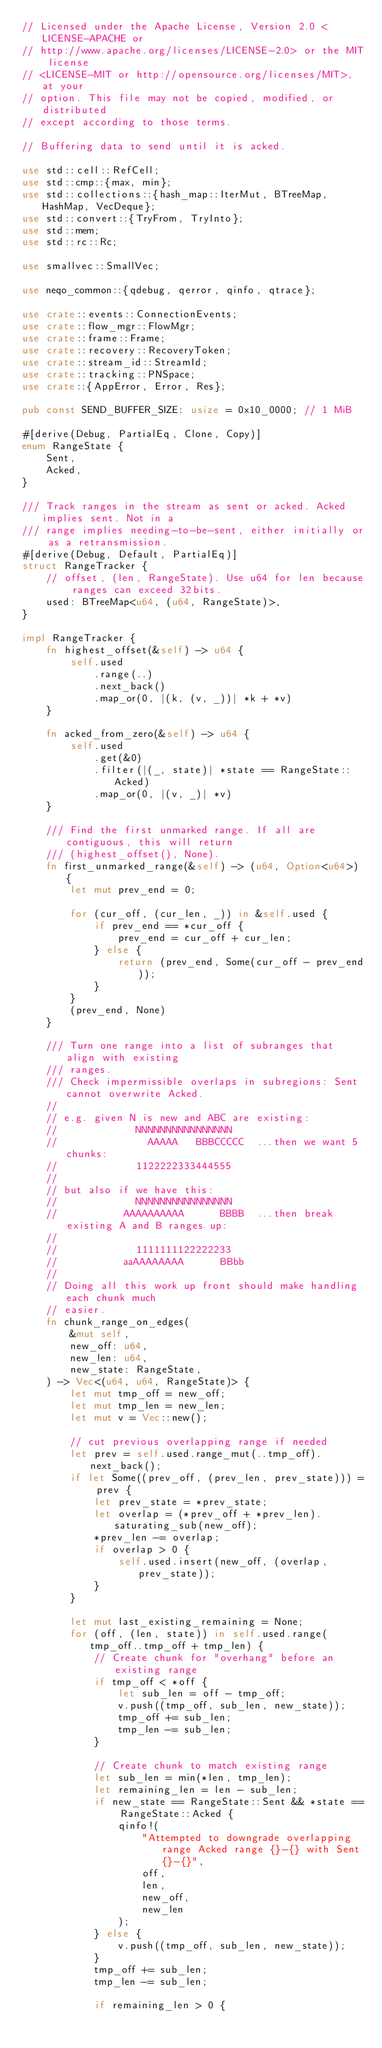Convert code to text. <code><loc_0><loc_0><loc_500><loc_500><_Rust_>// Licensed under the Apache License, Version 2.0 <LICENSE-APACHE or
// http://www.apache.org/licenses/LICENSE-2.0> or the MIT license
// <LICENSE-MIT or http://opensource.org/licenses/MIT>, at your
// option. This file may not be copied, modified, or distributed
// except according to those terms.

// Buffering data to send until it is acked.

use std::cell::RefCell;
use std::cmp::{max, min};
use std::collections::{hash_map::IterMut, BTreeMap, HashMap, VecDeque};
use std::convert::{TryFrom, TryInto};
use std::mem;
use std::rc::Rc;

use smallvec::SmallVec;

use neqo_common::{qdebug, qerror, qinfo, qtrace};

use crate::events::ConnectionEvents;
use crate::flow_mgr::FlowMgr;
use crate::frame::Frame;
use crate::recovery::RecoveryToken;
use crate::stream_id::StreamId;
use crate::tracking::PNSpace;
use crate::{AppError, Error, Res};

pub const SEND_BUFFER_SIZE: usize = 0x10_0000; // 1 MiB

#[derive(Debug, PartialEq, Clone, Copy)]
enum RangeState {
    Sent,
    Acked,
}

/// Track ranges in the stream as sent or acked. Acked implies sent. Not in a
/// range implies needing-to-be-sent, either initially or as a retransmission.
#[derive(Debug, Default, PartialEq)]
struct RangeTracker {
    // offset, (len, RangeState). Use u64 for len because ranges can exceed 32bits.
    used: BTreeMap<u64, (u64, RangeState)>,
}

impl RangeTracker {
    fn highest_offset(&self) -> u64 {
        self.used
            .range(..)
            .next_back()
            .map_or(0, |(k, (v, _))| *k + *v)
    }

    fn acked_from_zero(&self) -> u64 {
        self.used
            .get(&0)
            .filter(|(_, state)| *state == RangeState::Acked)
            .map_or(0, |(v, _)| *v)
    }

    /// Find the first unmarked range. If all are contiguous, this will return
    /// (highest_offset(), None).
    fn first_unmarked_range(&self) -> (u64, Option<u64>) {
        let mut prev_end = 0;

        for (cur_off, (cur_len, _)) in &self.used {
            if prev_end == *cur_off {
                prev_end = cur_off + cur_len;
            } else {
                return (prev_end, Some(cur_off - prev_end));
            }
        }
        (prev_end, None)
    }

    /// Turn one range into a list of subranges that align with existing
    /// ranges.
    /// Check impermissible overlaps in subregions: Sent cannot overwrite Acked.
    //
    // e.g. given N is new and ABC are existing:
    //             NNNNNNNNNNNNNNNN
    //               AAAAA   BBBCCCCC  ...then we want 5 chunks:
    //             1122222333444555
    //
    // but also if we have this:
    //             NNNNNNNNNNNNNNNN
    //           AAAAAAAAAA      BBBB  ...then break existing A and B ranges up:
    //
    //             1111111122222233
    //           aaAAAAAAAA      BBbb
    //
    // Doing all this work up front should make handling each chunk much
    // easier.
    fn chunk_range_on_edges(
        &mut self,
        new_off: u64,
        new_len: u64,
        new_state: RangeState,
    ) -> Vec<(u64, u64, RangeState)> {
        let mut tmp_off = new_off;
        let mut tmp_len = new_len;
        let mut v = Vec::new();

        // cut previous overlapping range if needed
        let prev = self.used.range_mut(..tmp_off).next_back();
        if let Some((prev_off, (prev_len, prev_state))) = prev {
            let prev_state = *prev_state;
            let overlap = (*prev_off + *prev_len).saturating_sub(new_off);
            *prev_len -= overlap;
            if overlap > 0 {
                self.used.insert(new_off, (overlap, prev_state));
            }
        }

        let mut last_existing_remaining = None;
        for (off, (len, state)) in self.used.range(tmp_off..tmp_off + tmp_len) {
            // Create chunk for "overhang" before an existing range
            if tmp_off < *off {
                let sub_len = off - tmp_off;
                v.push((tmp_off, sub_len, new_state));
                tmp_off += sub_len;
                tmp_len -= sub_len;
            }

            // Create chunk to match existing range
            let sub_len = min(*len, tmp_len);
            let remaining_len = len - sub_len;
            if new_state == RangeState::Sent && *state == RangeState::Acked {
                qinfo!(
                    "Attempted to downgrade overlapping range Acked range {}-{} with Sent {}-{}",
                    off,
                    len,
                    new_off,
                    new_len
                );
            } else {
                v.push((tmp_off, sub_len, new_state));
            }
            tmp_off += sub_len;
            tmp_len -= sub_len;

            if remaining_len > 0 {</code> 